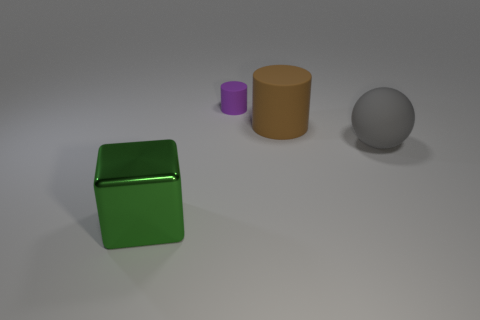Is there anything else that has the same material as the large green thing?
Keep it short and to the point. No. What number of tiny objects are gray matte spheres or yellow shiny balls?
Offer a very short reply. 0. What color is the other small thing that is the same shape as the brown matte thing?
Ensure brevity in your answer.  Purple. Is the size of the green object the same as the gray matte thing?
Your response must be concise. Yes. What number of objects are either big metallic blocks or large things on the left side of the purple matte cylinder?
Offer a very short reply. 1. The thing that is to the right of the big thing that is behind the gray thing is what color?
Offer a very short reply. Gray. What is the thing that is behind the brown matte thing made of?
Your answer should be very brief. Rubber. The green cube has what size?
Your response must be concise. Large. Are the large object behind the gray matte sphere and the big gray sphere made of the same material?
Your answer should be compact. Yes. How many tiny purple rubber cylinders are there?
Ensure brevity in your answer.  1. 